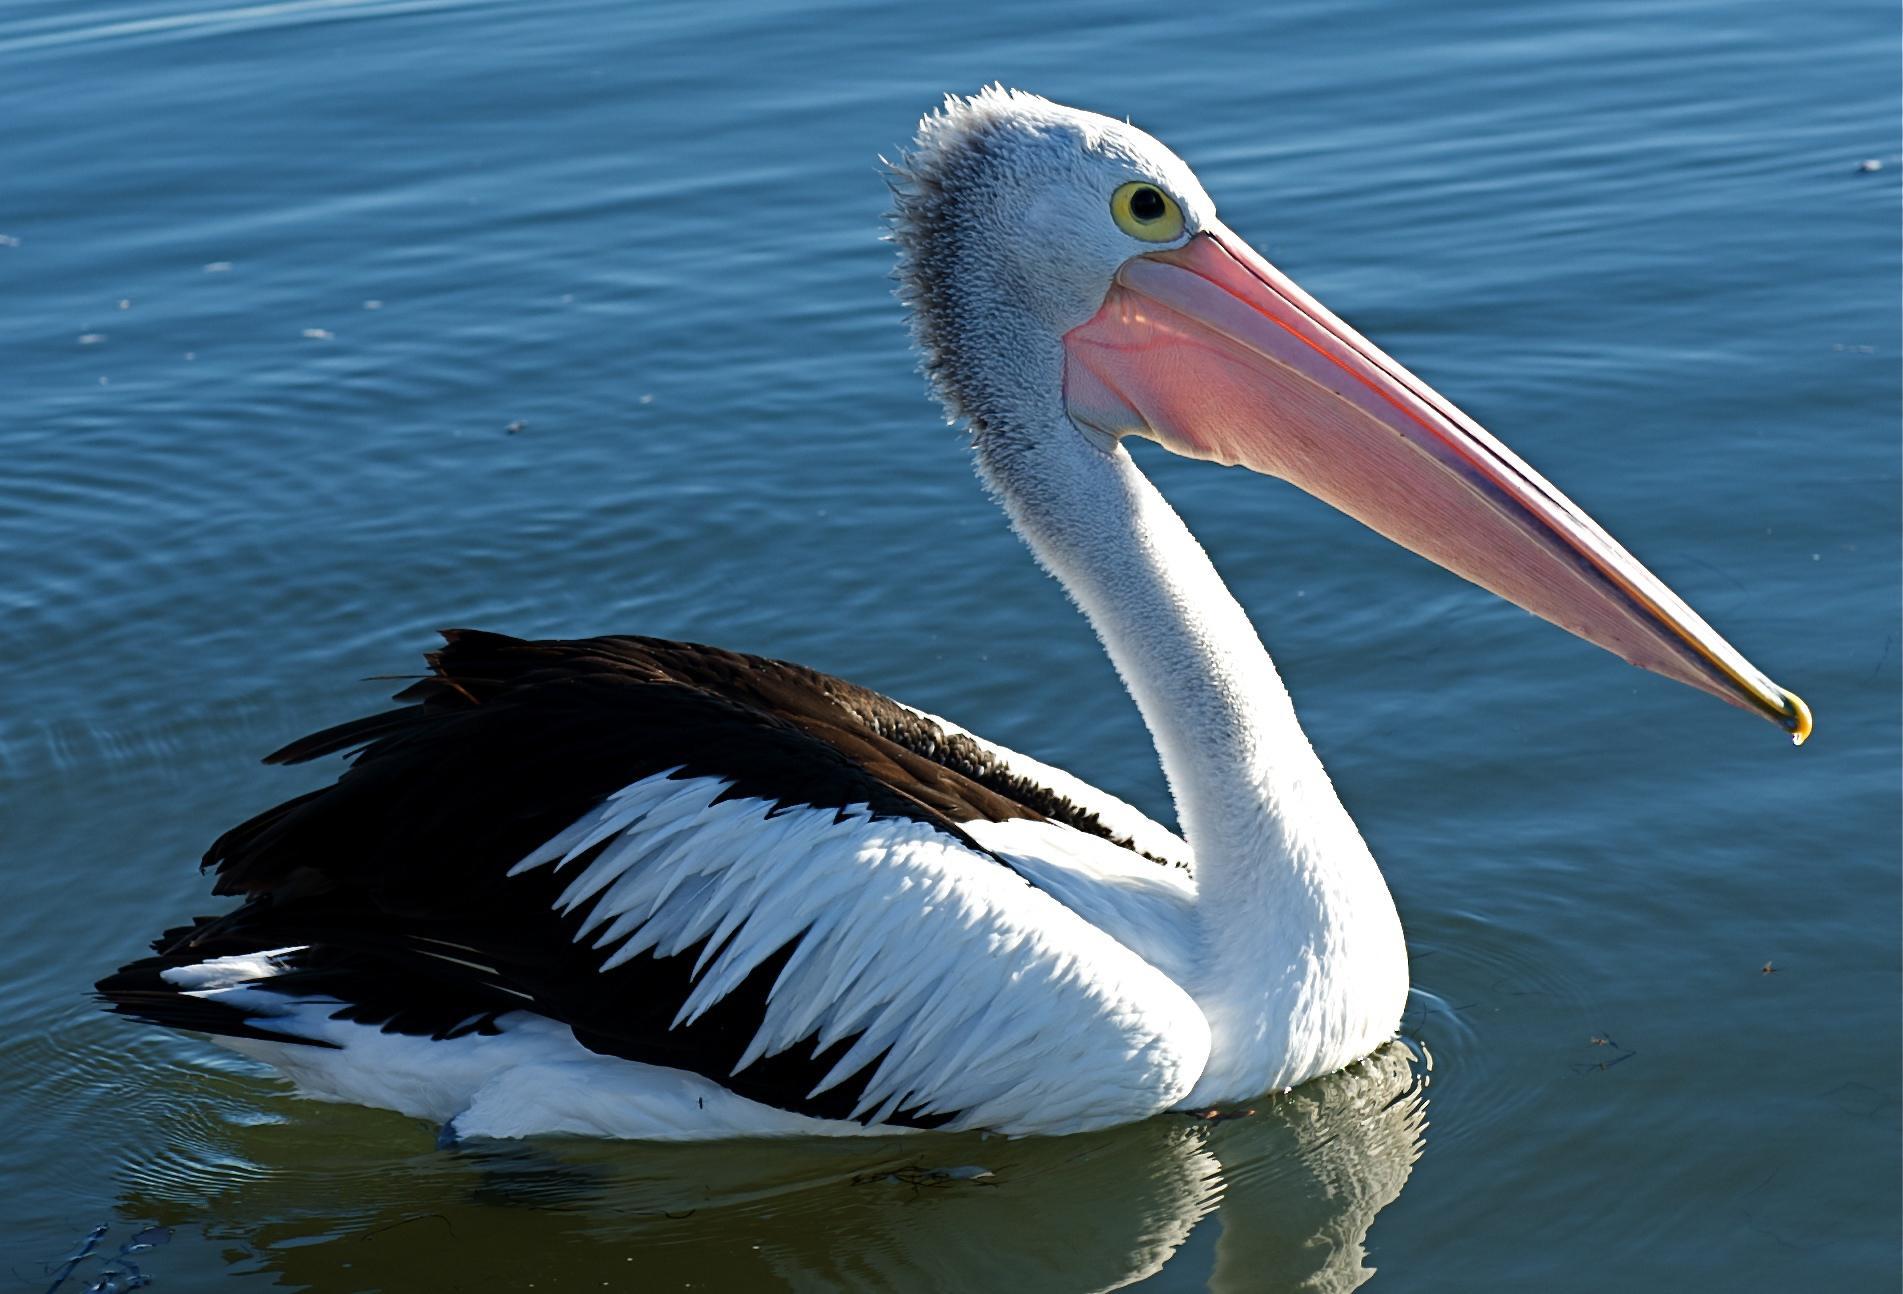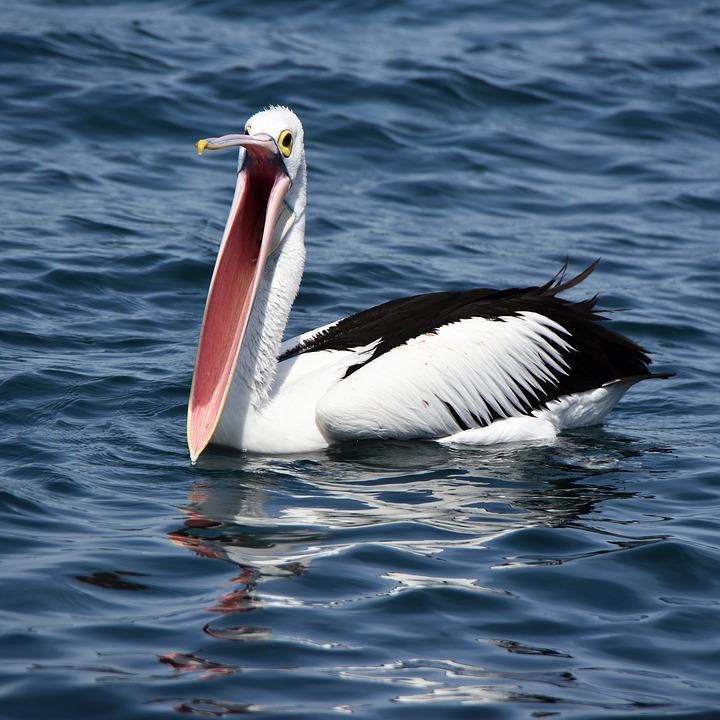The first image is the image on the left, the second image is the image on the right. For the images displayed, is the sentence "One image shows a pelican in flight." factually correct? Answer yes or no. No. 